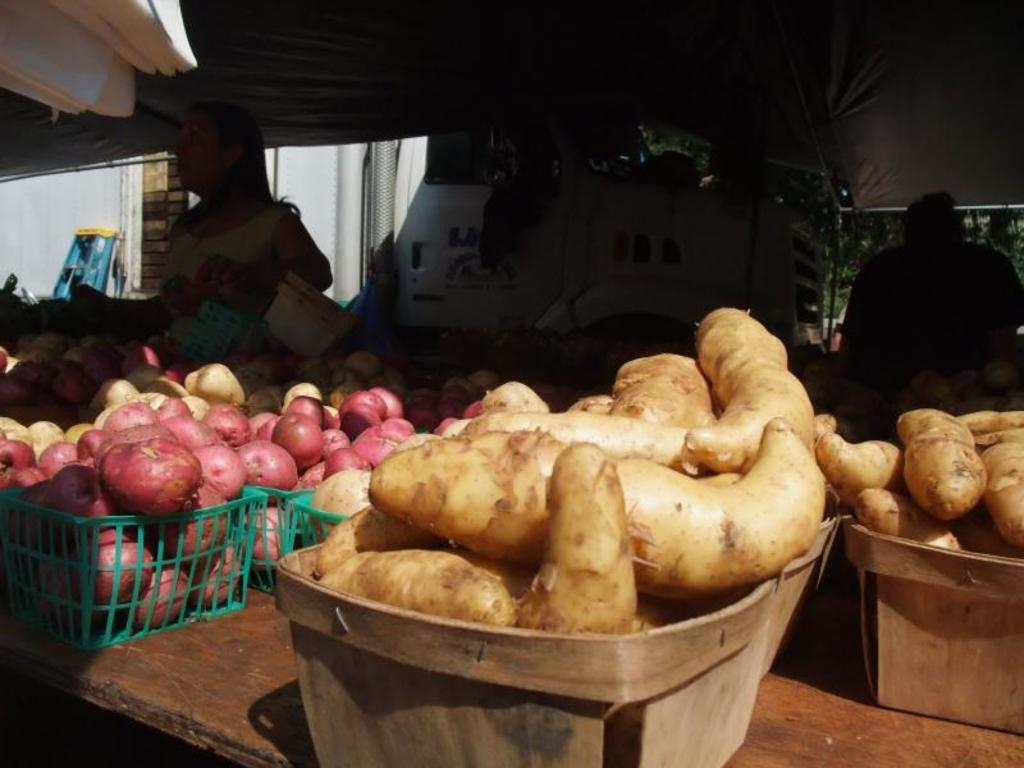What type of food is present on the table in the image? There are potatoes on the table in the image. What else can be seen on the table besides the potatoes? There are vegetables in baskets on the table. Can you describe the background of the image? The background of the image includes people. How would you describe the lighting in the image? The image appears to be dark. What type of road can be seen in the image? There is no road present in the image; it features potatoes and vegetables on a table with people in the background. 